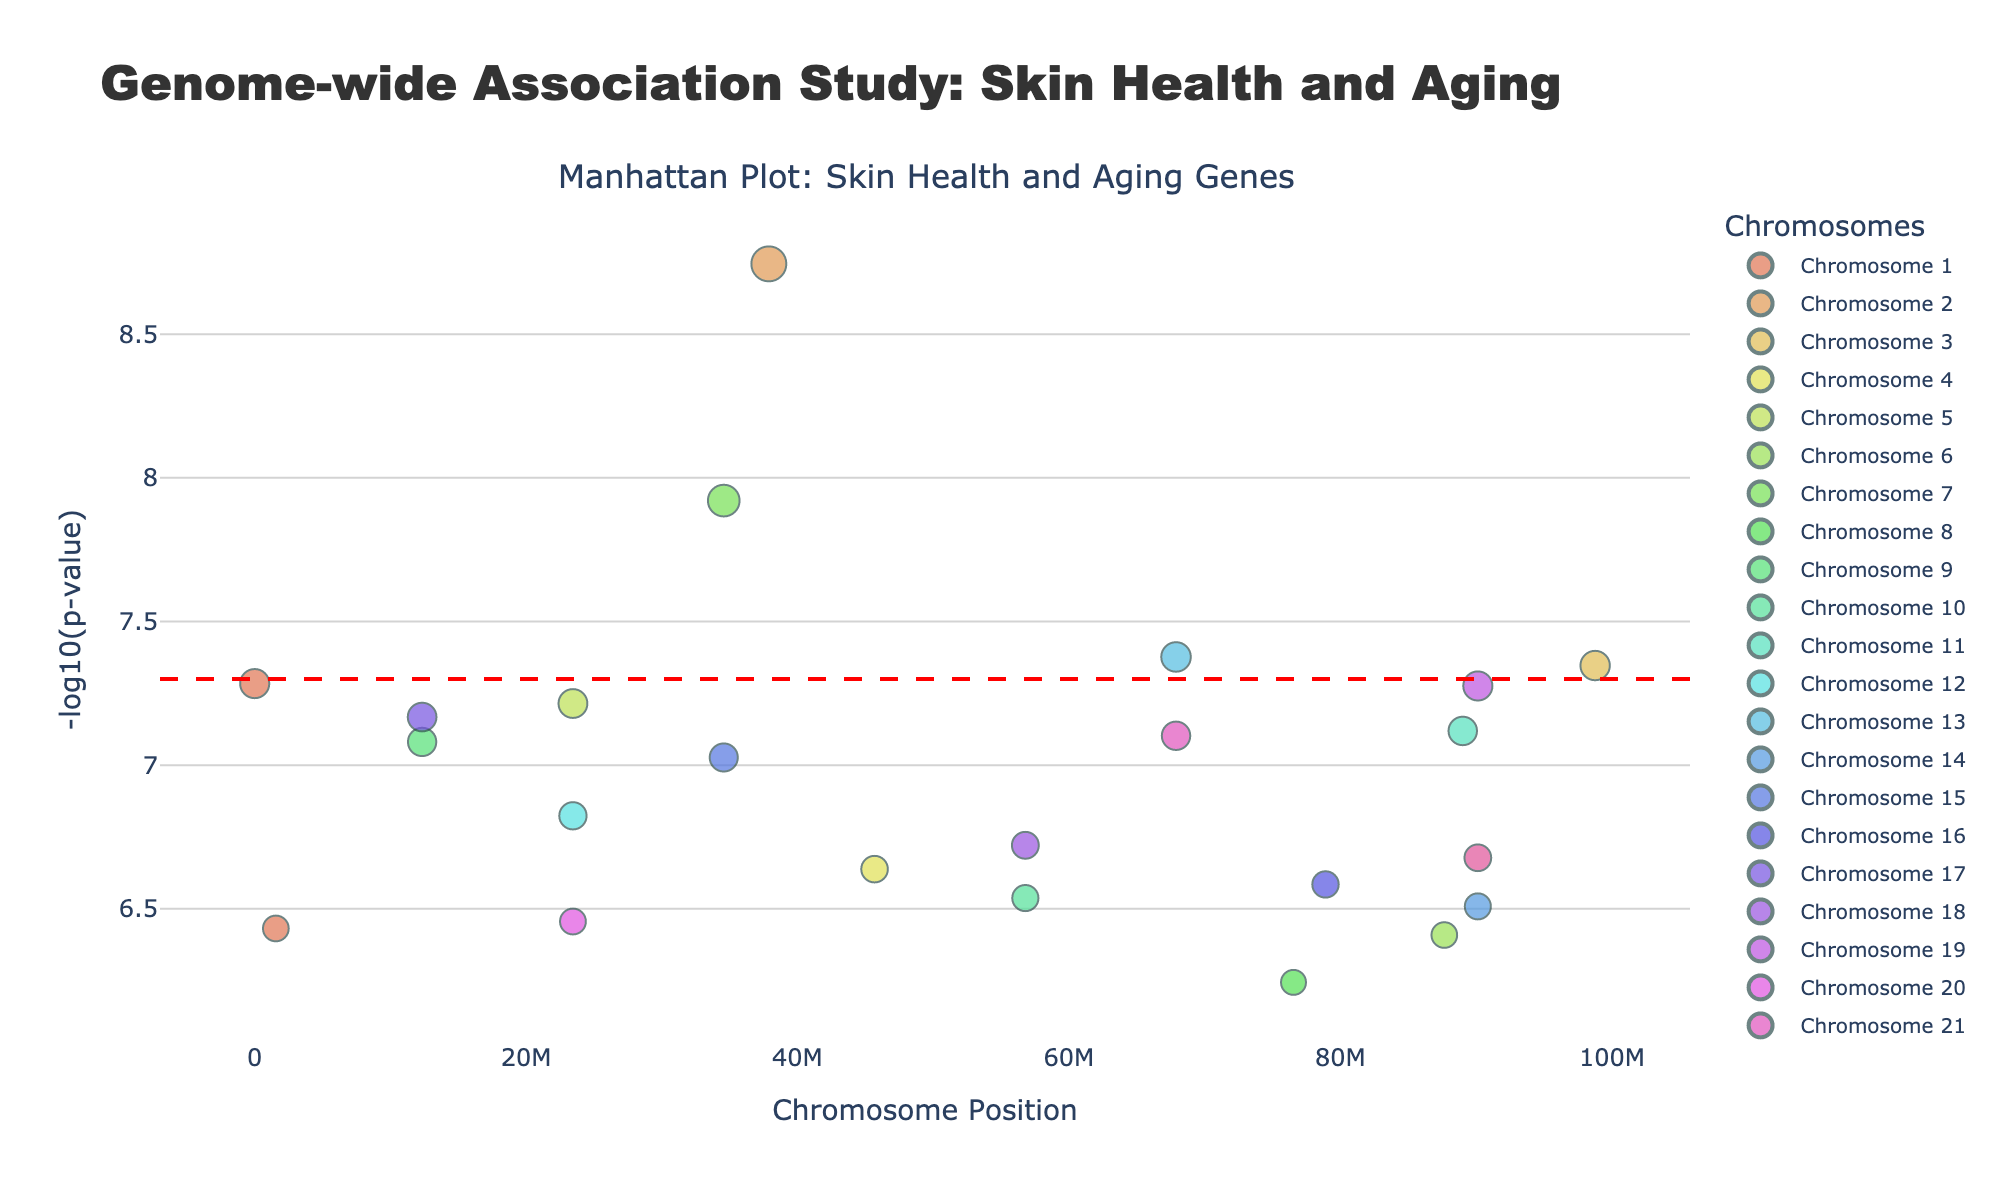How is the significance threshold marked in the plot? The significance threshold is marked with a horizontal red dashed line at -log10(p-value) = 7.3, which corresponds to a p-value of 5e-8.
Answer: A horizontal red dashed line at -log10(p-value) = 7.3 Which gene has the smallest p-value in the plot? The gene with the smallest p-value will have the highest -log10(p) value. By observing the y-axis, COL5A1 has the highest -log10(p) value, indicating the smallest p-value.
Answer: COL5A1 How many chromosomes are represented in the Manhattan Plot? Each unique color and label on the plot represents a chromosome. By counting the unique chromosome labels, we can verify that chromosomes 1 through 22 are represented.
Answer: 22 Which chromosome has the gene with the highest -log10(p) value? By observing the -log10(p) values on the y-axis and noting which chromosome the gene COL5A1 is located on, we can see it is on chromosome 2.
Answer: Chromosome 2 What is the position of the SNP (rs9876543) with the highest -log10(p) value? By identifying the SNP rs9876543 with the highest -log10(p) value in the plot and observing its position on the x-axis, we find the position to be at 37890123 on chromosome 2.
Answer: Position 37890123 How many genes have a -log10(p) value greater than 7.3? By examining the y-axis, counting the number of data points above the red dashed line (7.3 in -log10(p) value), we find that there are 5 such data points.
Answer: 5 Which gene is located at the highest position on chromosome 7? By looking at the data points specific to chromosome 7 and identifying the highest -log10(p) position, we find that it is CTNNB1.
Answer: CTNNB1 Name two genes with p-values less than or equal to 1e-7. By consulting the plot and identifying the genes above -log10(p-value) of 7, we see HNRNPCL1 and MMP1 as two such genes.
Answer: HNRNPCL1, MMP1 Which chromosome has the most significant association with skin health and aging? By identifying the chromosome that contains the gene with the highest -log10(p) value, it is chromosome 2 containing the gene COL5A1.
Answer: Chromosome 2 